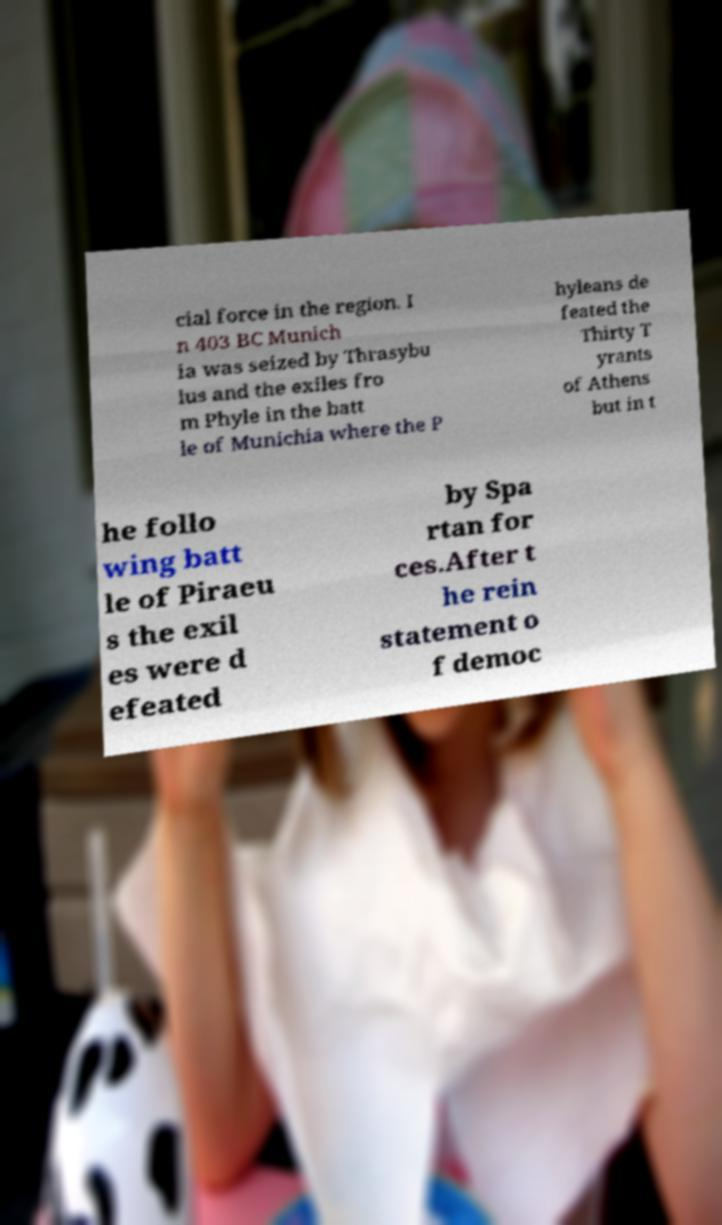There's text embedded in this image that I need extracted. Can you transcribe it verbatim? cial force in the region. I n 403 BC Munich ia was seized by Thrasybu lus and the exiles fro m Phyle in the batt le of Munichia where the P hyleans de feated the Thirty T yrants of Athens but in t he follo wing batt le of Piraeu s the exil es were d efeated by Spa rtan for ces.After t he rein statement o f democ 